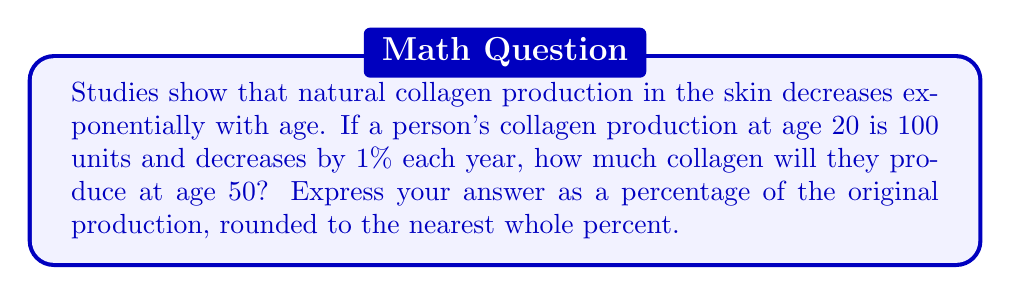Provide a solution to this math problem. Let's approach this step-by-step:

1) We can model this situation with an exponential decay function:
   $A(t) = A_0(1-r)^t$
   where $A(t)$ is the amount at time $t$, $A_0$ is the initial amount, and $r$ is the decay rate.

2) Given:
   - Initial collagen production (at age 20): $A_0 = 100$ units
   - Decay rate: $r = 1\% = 0.01$ per year
   - Time passed: $t = 50 - 20 = 30$ years

3) Plugging into our formula:
   $A(30) = 100(1-0.01)^{30}$

4) Simplify:
   $A(30) = 100(0.99)^{30}$

5) Calculate:
   $A(30) = 100 \times 0.7397 = 73.97$ units

6) To express this as a percentage of the original production:
   $\frac{73.97}{100} \times 100\% = 73.97\%$

7) Rounding to the nearest whole percent:
   $73.97\% \approx 74\%$

This result shows that by age 50, a person will produce approximately 74% of the collagen they produced at age 20, highlighting the significant decrease in natural collagen production over time.
Answer: 74% 